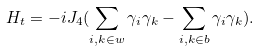Convert formula to latex. <formula><loc_0><loc_0><loc_500><loc_500>H _ { t } = - i J _ { 4 } ( \sum _ { i , k \in w } \gamma _ { i } \gamma _ { k } - \sum _ { i , k \in b } \gamma _ { i } \gamma _ { k } ) .</formula> 